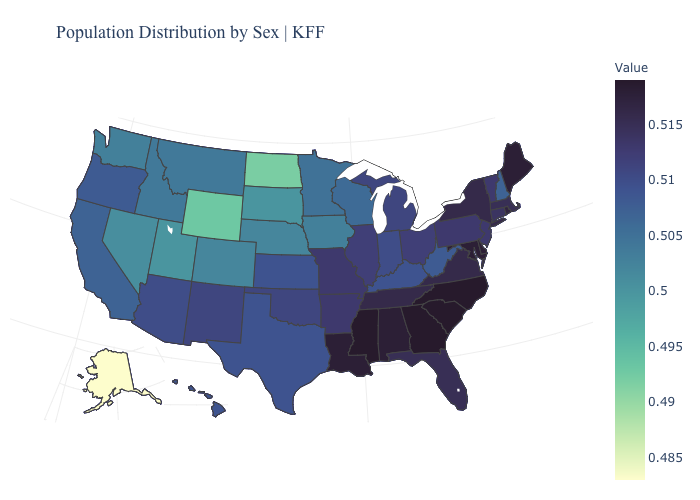Among the states that border West Virginia , which have the highest value?
Keep it brief. Maryland. Among the states that border Utah , which have the lowest value?
Concise answer only. Wyoming. Does Delaware have the highest value in the USA?
Keep it brief. No. Does Alaska have the lowest value in the USA?
Quick response, please. Yes. Does Minnesota have the lowest value in the MidWest?
Concise answer only. No. Does the map have missing data?
Keep it brief. No. Does the map have missing data?
Write a very short answer. No. 